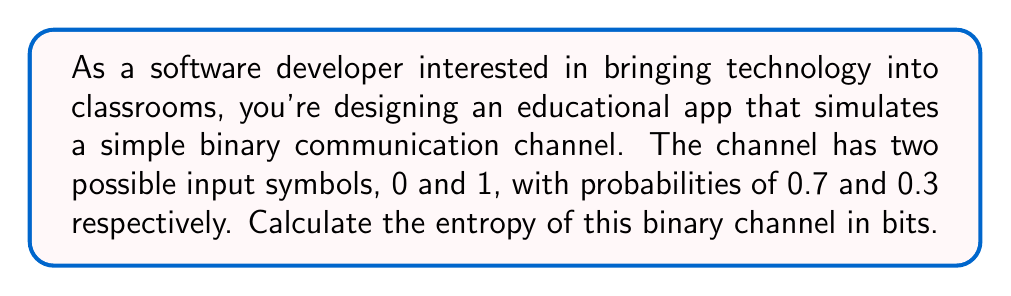Solve this math problem. To calculate the entropy of a binary communication channel, we use the formula for Shannon entropy:

$$H = -\sum_{i=1}^n p_i \log_2(p_i)$$

Where:
- $H$ is the entropy in bits
- $p_i$ is the probability of each symbol
- $n$ is the number of possible symbols (in this case, 2)

Let's break it down step by step:

1. We have two symbols: 0 with probability 0.7, and 1 with probability 0.3

2. Calculate the contribution of each symbol to the entropy:
   For 0: $-0.7 \log_2(0.7)$
   For 1: $-0.3 \log_2(0.3)$

3. Calculate each term:
   $-0.7 \log_2(0.7) \approx 0.7 \times 0.5146 \approx 0.3602$
   $-0.3 \log_2(0.3) \approx 0.3 \times 1.7370 \approx 0.5211$

4. Sum the terms:
   $H = 0.3602 + 0.5211 = 0.8813$

Therefore, the entropy of the binary channel is approximately 0.8813 bits.
Answer: The entropy of the binary communication channel is approximately 0.8813 bits. 